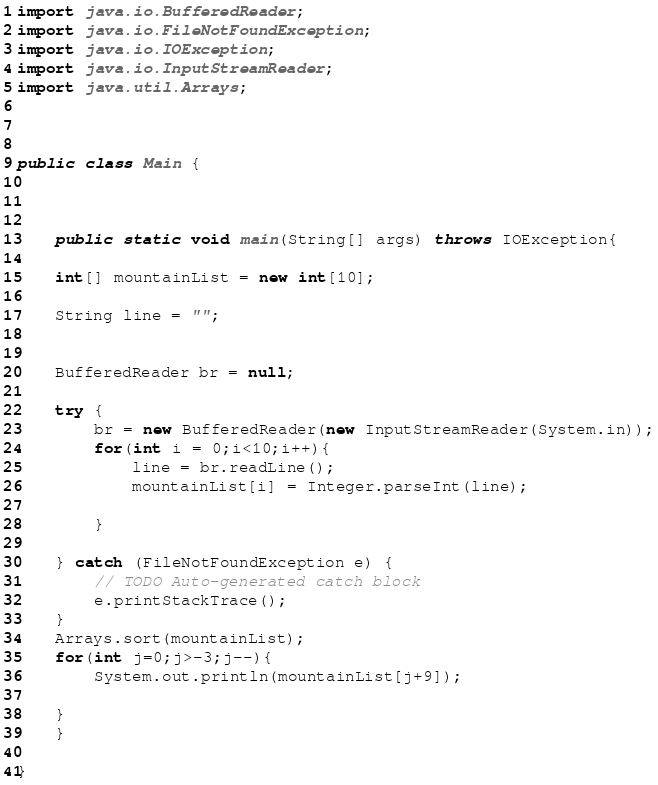<code> <loc_0><loc_0><loc_500><loc_500><_Java_>import java.io.BufferedReader;
import java.io.FileNotFoundException;
import java.io.IOException;
import java.io.InputStreamReader;
import java.util.Arrays;



public class Main {

	
	
	public static void main(String[] args) throws IOException{
    
	int[] mountainList = new int[10];
	
	String line = "";
		
	
	BufferedReader br = null;
			
	try {
		br = new BufferedReader(new InputStreamReader(System.in));
		for(int i = 0;i<10;i++){
			line = br.readLine();
			mountainList[i] = Integer.parseInt(line);
				
		}
		
	} catch (FileNotFoundException e) {
		// TODO Auto-generated catch block
		e.printStackTrace();
	}
	Arrays.sort(mountainList);
	for(int j=0;j>-3;j--){
		System.out.println(mountainList[j+9]);
		
	}
	}

}</code> 